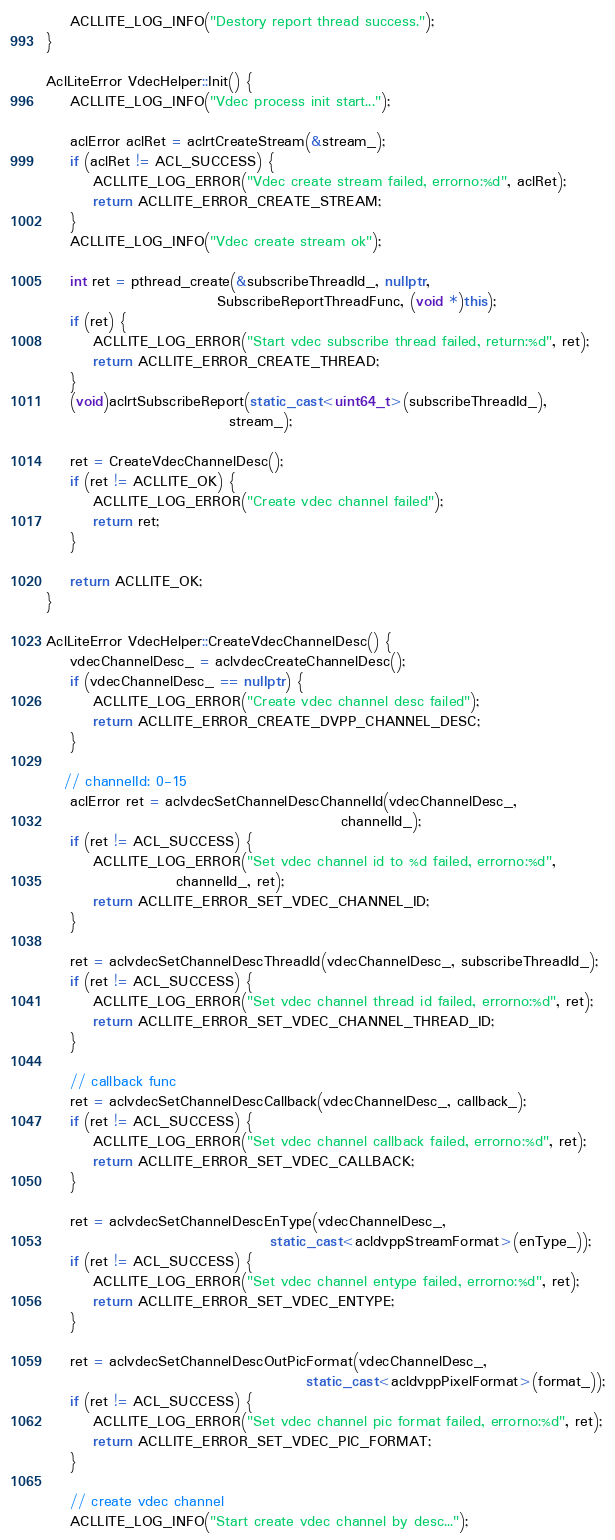<code> <loc_0><loc_0><loc_500><loc_500><_C++_>    ACLLITE_LOG_INFO("Destory report thread success.");
}

AclLiteError VdecHelper::Init() {
    ACLLITE_LOG_INFO("Vdec process init start...");
    
    aclError aclRet = aclrtCreateStream(&stream_);
    if (aclRet != ACL_SUCCESS) {
        ACLLITE_LOG_ERROR("Vdec create stream failed, errorno:%d", aclRet);
        return ACLLITE_ERROR_CREATE_STREAM;
    }
    ACLLITE_LOG_INFO("Vdec create stream ok");
         
    int ret = pthread_create(&subscribeThreadId_, nullptr, 
                             SubscribeReportThreadFunc, (void *)this);
    if (ret) {
        ACLLITE_LOG_ERROR("Start vdec subscribe thread failed, return:%d", ret);
        return ACLLITE_ERROR_CREATE_THREAD;
    }
    (void)aclrtSubscribeReport(static_cast<uint64_t>(subscribeThreadId_), 
                               stream_);

    ret = CreateVdecChannelDesc();
    if (ret != ACLLITE_OK) {
        ACLLITE_LOG_ERROR("Create vdec channel failed");
        return ret;
    }

    return ACLLITE_OK;
}

AclLiteError VdecHelper::CreateVdecChannelDesc() {
    vdecChannelDesc_ = aclvdecCreateChannelDesc();
    if (vdecChannelDesc_ == nullptr) {
        ACLLITE_LOG_ERROR("Create vdec channel desc failed");
        return ACLLITE_ERROR_CREATE_DVPP_CHANNEL_DESC;
    }

   // channelId: 0-15
    aclError ret = aclvdecSetChannelDescChannelId(vdecChannelDesc_,
                                                  channelId_);
    if (ret != ACL_SUCCESS) {
        ACLLITE_LOG_ERROR("Set vdec channel id to %d failed, errorno:%d", 
                      channelId_, ret);
        return ACLLITE_ERROR_SET_VDEC_CHANNEL_ID;
    }

    ret = aclvdecSetChannelDescThreadId(vdecChannelDesc_, subscribeThreadId_);
    if (ret != ACL_SUCCESS) {
        ACLLITE_LOG_ERROR("Set vdec channel thread id failed, errorno:%d", ret);
        return ACLLITE_ERROR_SET_VDEC_CHANNEL_THREAD_ID;
    }

    // callback func
    ret = aclvdecSetChannelDescCallback(vdecChannelDesc_, callback_);
    if (ret != ACL_SUCCESS) {
        ACLLITE_LOG_ERROR("Set vdec channel callback failed, errorno:%d", ret);
        return ACLLITE_ERROR_SET_VDEC_CALLBACK;
    }

    ret = aclvdecSetChannelDescEnType(vdecChannelDesc_, 
                                      static_cast<acldvppStreamFormat>(enType_));
    if (ret != ACL_SUCCESS) {
        ACLLITE_LOG_ERROR("Set vdec channel entype failed, errorno:%d", ret);
        return ACLLITE_ERROR_SET_VDEC_ENTYPE;
    }

    ret = aclvdecSetChannelDescOutPicFormat(vdecChannelDesc_, 
                                            static_cast<acldvppPixelFormat>(format_));
    if (ret != ACL_SUCCESS) {
        ACLLITE_LOG_ERROR("Set vdec channel pic format failed, errorno:%d", ret);
        return ACLLITE_ERROR_SET_VDEC_PIC_FORMAT;
    }

    // create vdec channel
    ACLLITE_LOG_INFO("Start create vdec channel by desc...");</code> 